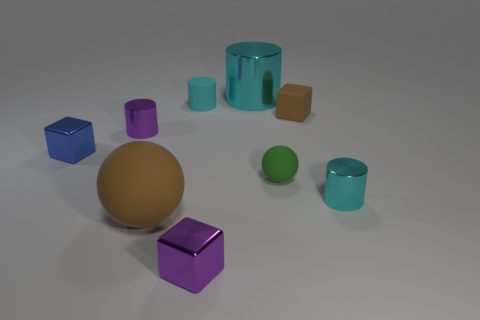There is a cylinder that is made of the same material as the brown sphere; what color is it?
Keep it short and to the point. Cyan. How many metallic things are either large cyan cylinders or small purple cubes?
Provide a succinct answer. 2. Is the tiny blue object made of the same material as the big cyan cylinder?
Provide a short and direct response. Yes. There is a purple object that is left of the small purple metal block; what shape is it?
Provide a short and direct response. Cylinder. Are there any large rubber objects that are in front of the small purple object in front of the tiny blue metal object?
Give a very brief answer. No. Is there a brown object of the same size as the blue object?
Provide a short and direct response. Yes. Is the color of the large thing that is in front of the small blue metallic cube the same as the rubber cube?
Your answer should be compact. Yes. The brown rubber ball has what size?
Your answer should be compact. Large. There is a shiny cylinder in front of the tiny object that is on the left side of the small purple metal cylinder; what is its size?
Your answer should be very brief. Small. How many other matte cylinders are the same color as the big cylinder?
Make the answer very short. 1. 